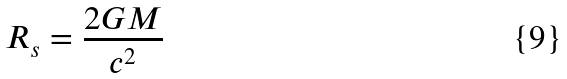Convert formula to latex. <formula><loc_0><loc_0><loc_500><loc_500>R _ { s } = \frac { 2 G M } { c ^ { 2 } }</formula> 